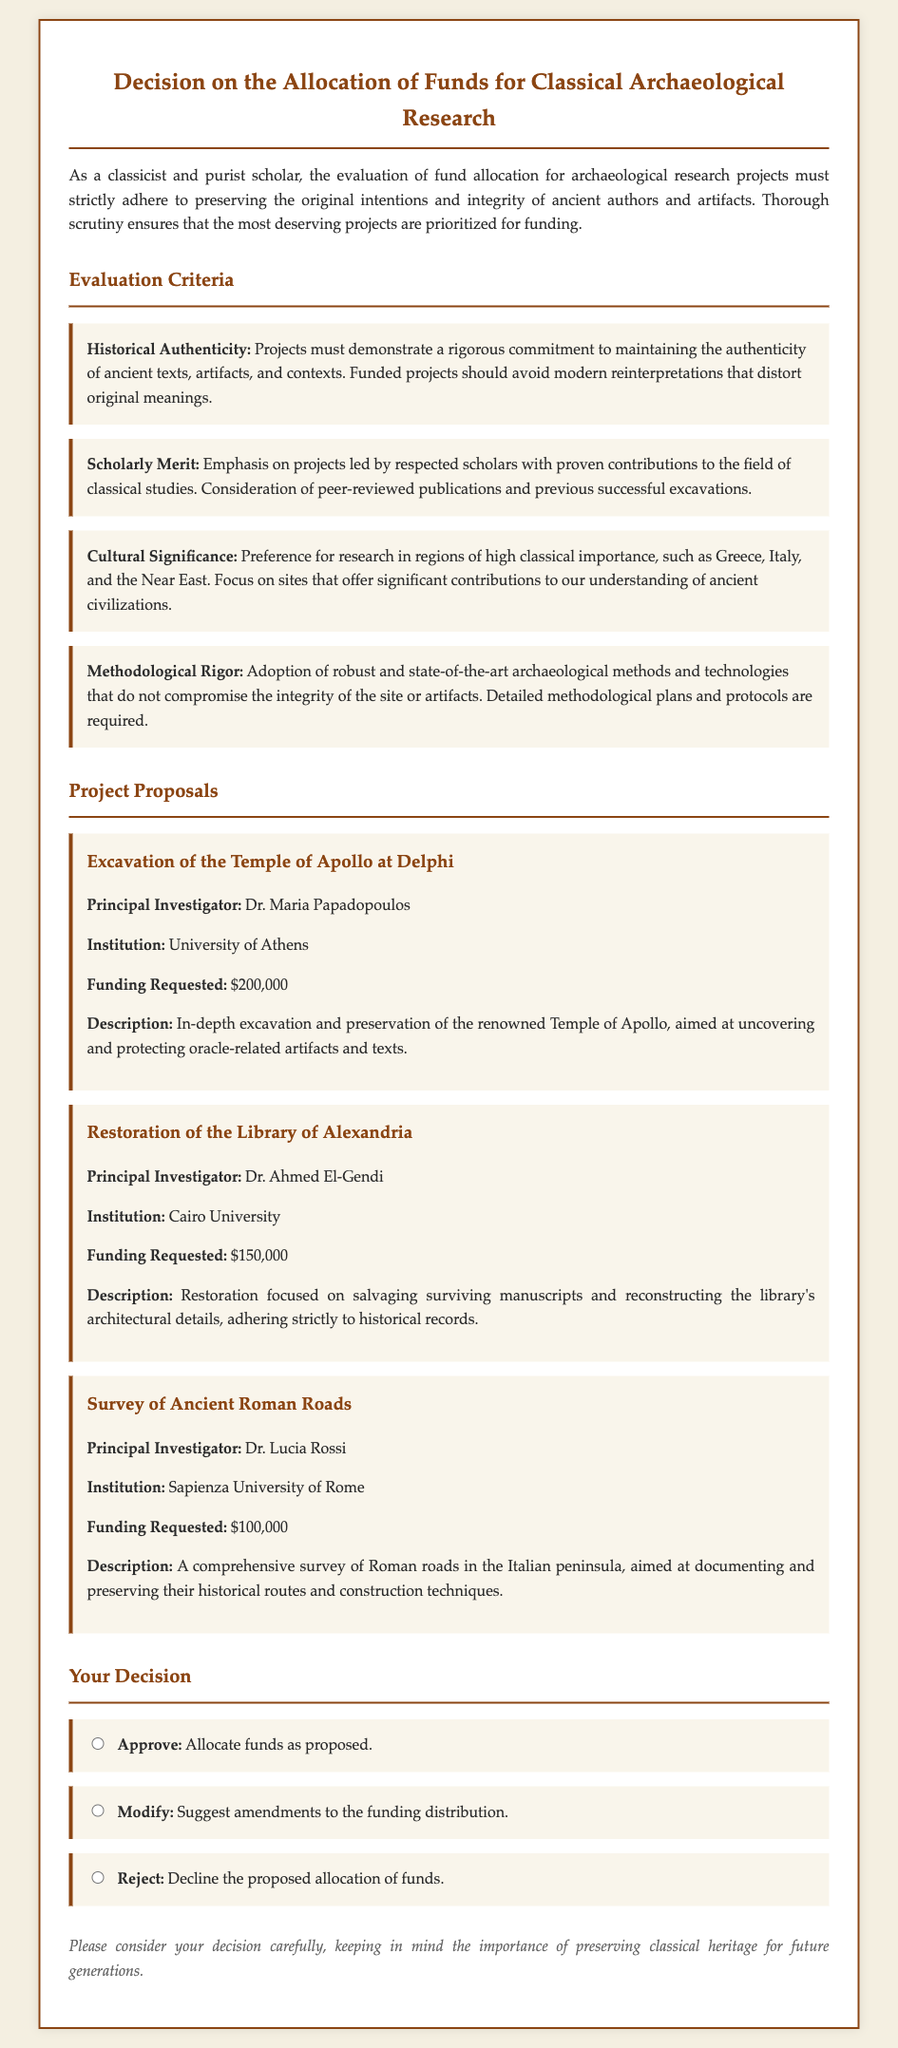what is the title of the document? The title is presented at the top of the document and states the purpose clearly.
Answer: Decision on the Allocation of Funds for Classical Archaeological Research who is the principal investigator for the excavation of the Temple of Apollo? The principal investigator's name is listed under each project proposal.
Answer: Dr. Maria Papadopoulos how much funding is requested for the restoration of the Library of Alexandria? The amount requested for this project is specified directly in the proposal section.
Answer: $150,000 what is one of the evaluation criteria mentioned in the document? The document lists several criteria for evaluation.
Answer: Historical Authenticity which institution is associated with the survey of ancient Roman roads? The institution is mentioned as part of the project details.
Answer: Sapienza University of Rome what decision options are provided in the document? The document specifies three distinct choices regarding funding allocation.
Answer: Approve, Modify, Reject how many projects are proposed in the document? The total number of projects can be counted from the project proposal section.
Answer: 3 which project focuses on oracle-related artifacts? The specific project related to oracle artifacts is outlined in the project proposal.
Answer: Excavation of the Temple of Apollo at Delphi what color scheme is used for the headings in the document? The color used for headings is described in the style section of the document.
Answer: #8b4513 